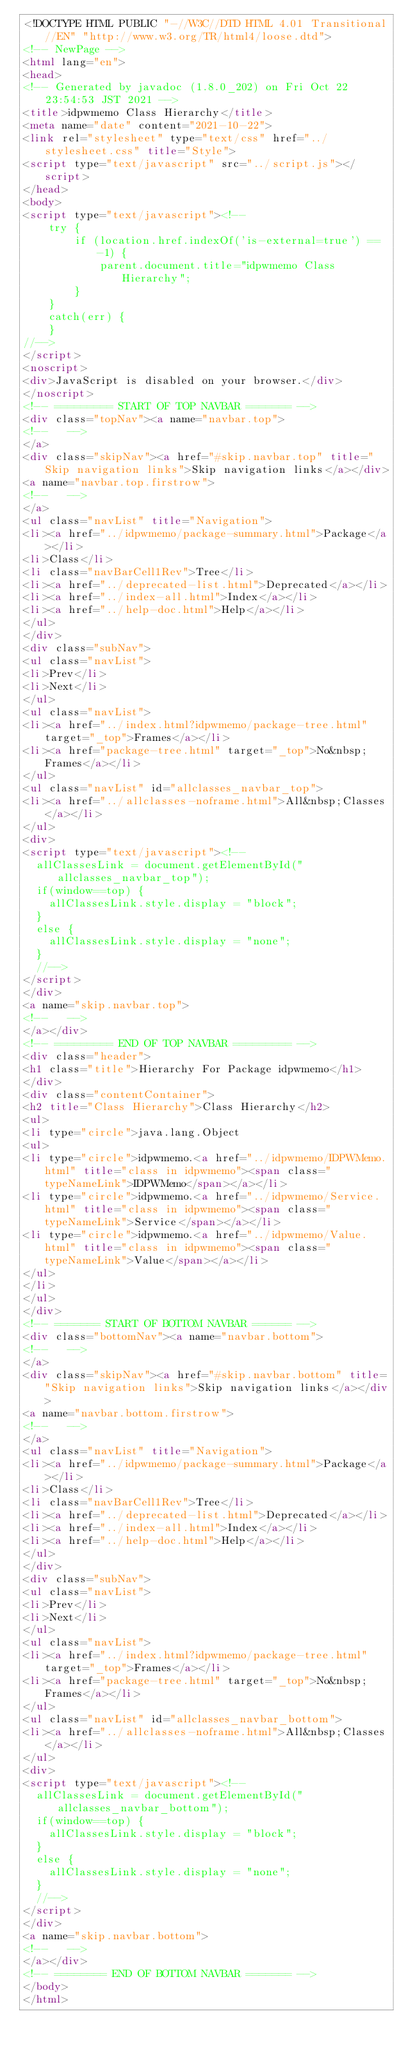Convert code to text. <code><loc_0><loc_0><loc_500><loc_500><_HTML_><!DOCTYPE HTML PUBLIC "-//W3C//DTD HTML 4.01 Transitional//EN" "http://www.w3.org/TR/html4/loose.dtd">
<!-- NewPage -->
<html lang="en">
<head>
<!-- Generated by javadoc (1.8.0_202) on Fri Oct 22 23:54:53 JST 2021 -->
<title>idpwmemo Class Hierarchy</title>
<meta name="date" content="2021-10-22">
<link rel="stylesheet" type="text/css" href="../stylesheet.css" title="Style">
<script type="text/javascript" src="../script.js"></script>
</head>
<body>
<script type="text/javascript"><!--
    try {
        if (location.href.indexOf('is-external=true') == -1) {
            parent.document.title="idpwmemo Class Hierarchy";
        }
    }
    catch(err) {
    }
//-->
</script>
<noscript>
<div>JavaScript is disabled on your browser.</div>
</noscript>
<!-- ========= START OF TOP NAVBAR ======= -->
<div class="topNav"><a name="navbar.top">
<!--   -->
</a>
<div class="skipNav"><a href="#skip.navbar.top" title="Skip navigation links">Skip navigation links</a></div>
<a name="navbar.top.firstrow">
<!--   -->
</a>
<ul class="navList" title="Navigation">
<li><a href="../idpwmemo/package-summary.html">Package</a></li>
<li>Class</li>
<li class="navBarCell1Rev">Tree</li>
<li><a href="../deprecated-list.html">Deprecated</a></li>
<li><a href="../index-all.html">Index</a></li>
<li><a href="../help-doc.html">Help</a></li>
</ul>
</div>
<div class="subNav">
<ul class="navList">
<li>Prev</li>
<li>Next</li>
</ul>
<ul class="navList">
<li><a href="../index.html?idpwmemo/package-tree.html" target="_top">Frames</a></li>
<li><a href="package-tree.html" target="_top">No&nbsp;Frames</a></li>
</ul>
<ul class="navList" id="allclasses_navbar_top">
<li><a href="../allclasses-noframe.html">All&nbsp;Classes</a></li>
</ul>
<div>
<script type="text/javascript"><!--
  allClassesLink = document.getElementById("allclasses_navbar_top");
  if(window==top) {
    allClassesLink.style.display = "block";
  }
  else {
    allClassesLink.style.display = "none";
  }
  //-->
</script>
</div>
<a name="skip.navbar.top">
<!--   -->
</a></div>
<!-- ========= END OF TOP NAVBAR ========= -->
<div class="header">
<h1 class="title">Hierarchy For Package idpwmemo</h1>
</div>
<div class="contentContainer">
<h2 title="Class Hierarchy">Class Hierarchy</h2>
<ul>
<li type="circle">java.lang.Object
<ul>
<li type="circle">idpwmemo.<a href="../idpwmemo/IDPWMemo.html" title="class in idpwmemo"><span class="typeNameLink">IDPWMemo</span></a></li>
<li type="circle">idpwmemo.<a href="../idpwmemo/Service.html" title="class in idpwmemo"><span class="typeNameLink">Service</span></a></li>
<li type="circle">idpwmemo.<a href="../idpwmemo/Value.html" title="class in idpwmemo"><span class="typeNameLink">Value</span></a></li>
</ul>
</li>
</ul>
</div>
<!-- ======= START OF BOTTOM NAVBAR ====== -->
<div class="bottomNav"><a name="navbar.bottom">
<!--   -->
</a>
<div class="skipNav"><a href="#skip.navbar.bottom" title="Skip navigation links">Skip navigation links</a></div>
<a name="navbar.bottom.firstrow">
<!--   -->
</a>
<ul class="navList" title="Navigation">
<li><a href="../idpwmemo/package-summary.html">Package</a></li>
<li>Class</li>
<li class="navBarCell1Rev">Tree</li>
<li><a href="../deprecated-list.html">Deprecated</a></li>
<li><a href="../index-all.html">Index</a></li>
<li><a href="../help-doc.html">Help</a></li>
</ul>
</div>
<div class="subNav">
<ul class="navList">
<li>Prev</li>
<li>Next</li>
</ul>
<ul class="navList">
<li><a href="../index.html?idpwmemo/package-tree.html" target="_top">Frames</a></li>
<li><a href="package-tree.html" target="_top">No&nbsp;Frames</a></li>
</ul>
<ul class="navList" id="allclasses_navbar_bottom">
<li><a href="../allclasses-noframe.html">All&nbsp;Classes</a></li>
</ul>
<div>
<script type="text/javascript"><!--
  allClassesLink = document.getElementById("allclasses_navbar_bottom");
  if(window==top) {
    allClassesLink.style.display = "block";
  }
  else {
    allClassesLink.style.display = "none";
  }
  //-->
</script>
</div>
<a name="skip.navbar.bottom">
<!--   -->
</a></div>
<!-- ======== END OF BOTTOM NAVBAR ======= -->
</body>
</html>
</code> 